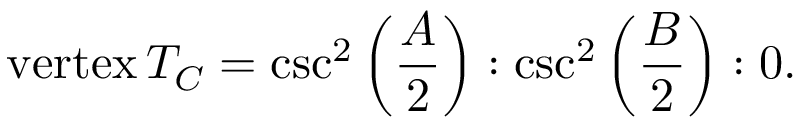Convert formula to latex. <formula><loc_0><loc_0><loc_500><loc_500>{ v e r t e x } \, T _ { C } = \csc ^ { 2 } \left ( { \frac { A } { 2 } } \right ) \colon \csc ^ { 2 } \left ( { \frac { B } { 2 } } \right ) \colon 0 .</formula> 